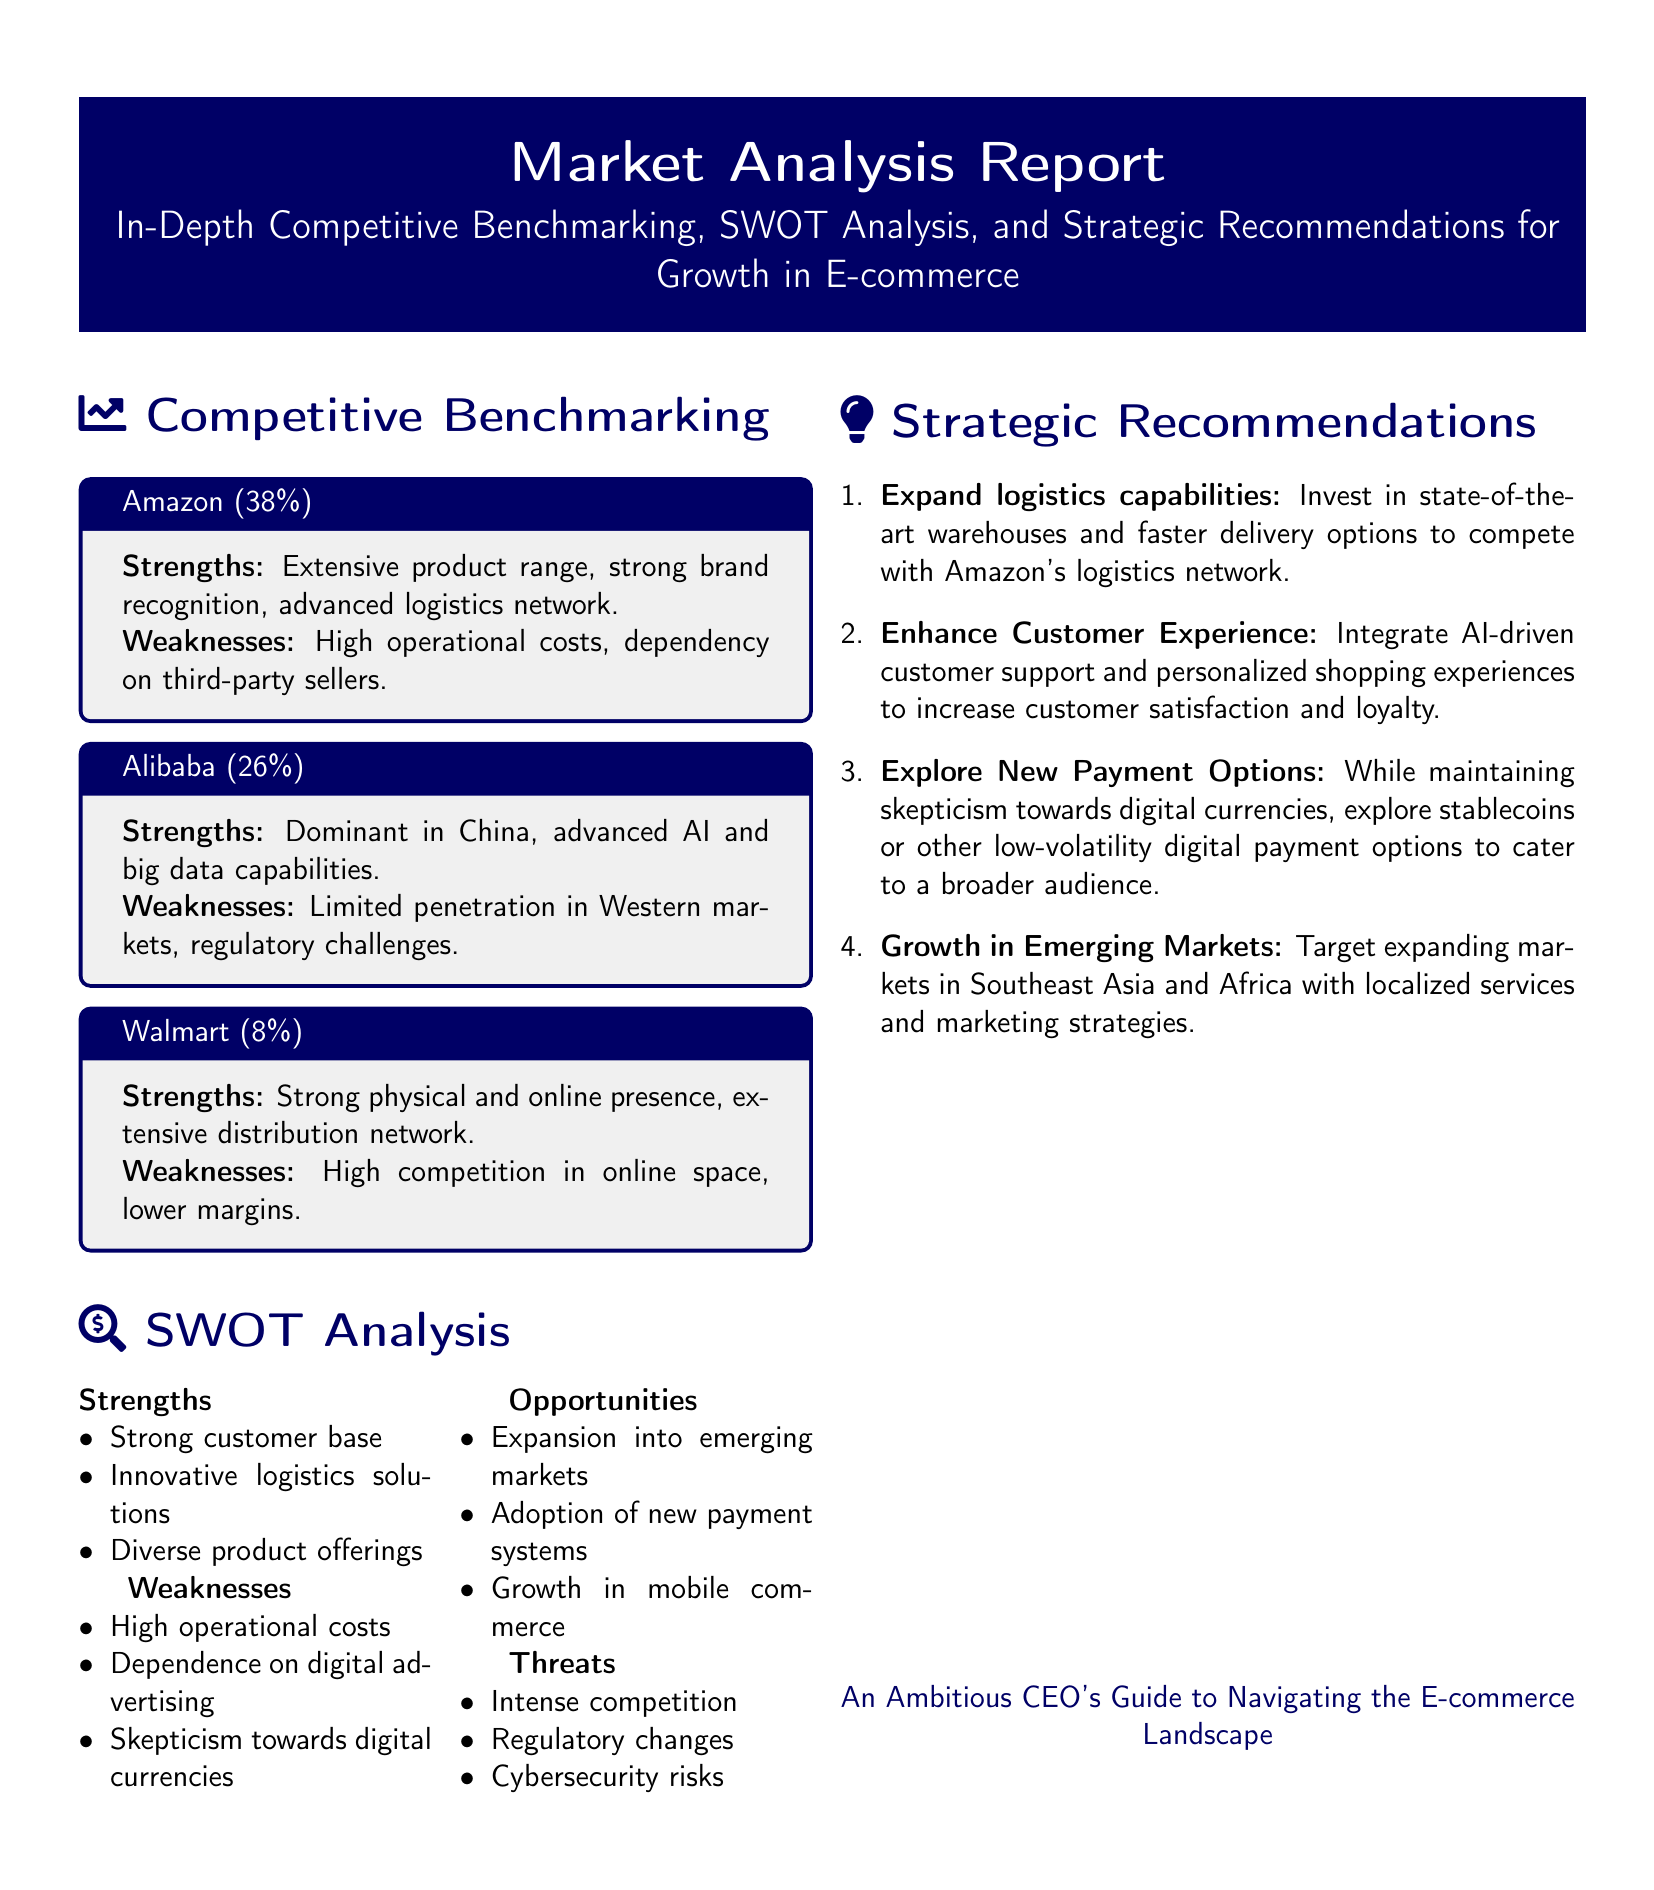What percentage of the market does Amazon hold? Amazon holds 38% of the market according to the competitive benchmarking section.
Answer: 38% What is a weakness of Alibaba? The weakness of Alibaba is its limited penetration in Western markets as mentioned in the competitive benchmarking section.
Answer: Limited penetration in Western markets What are the strengths listed in the SWOT analysis? The strengths listed in the SWOT analysis include a strong customer base, innovative logistics solutions, and diverse product offerings.
Answer: Strong customer base, innovative logistics solutions, diverse product offerings What is one strategic recommendation for growth? One strategic recommendation for growth is to expand logistics capabilities by investing in state-of-the-art warehouses and faster delivery options.
Answer: Expand logistics capabilities What is a major threat to the e-commerce industry? A major threat to the e-commerce industry is intense competition, as outlined in the SWOT analysis section.
Answer: Intense competition 